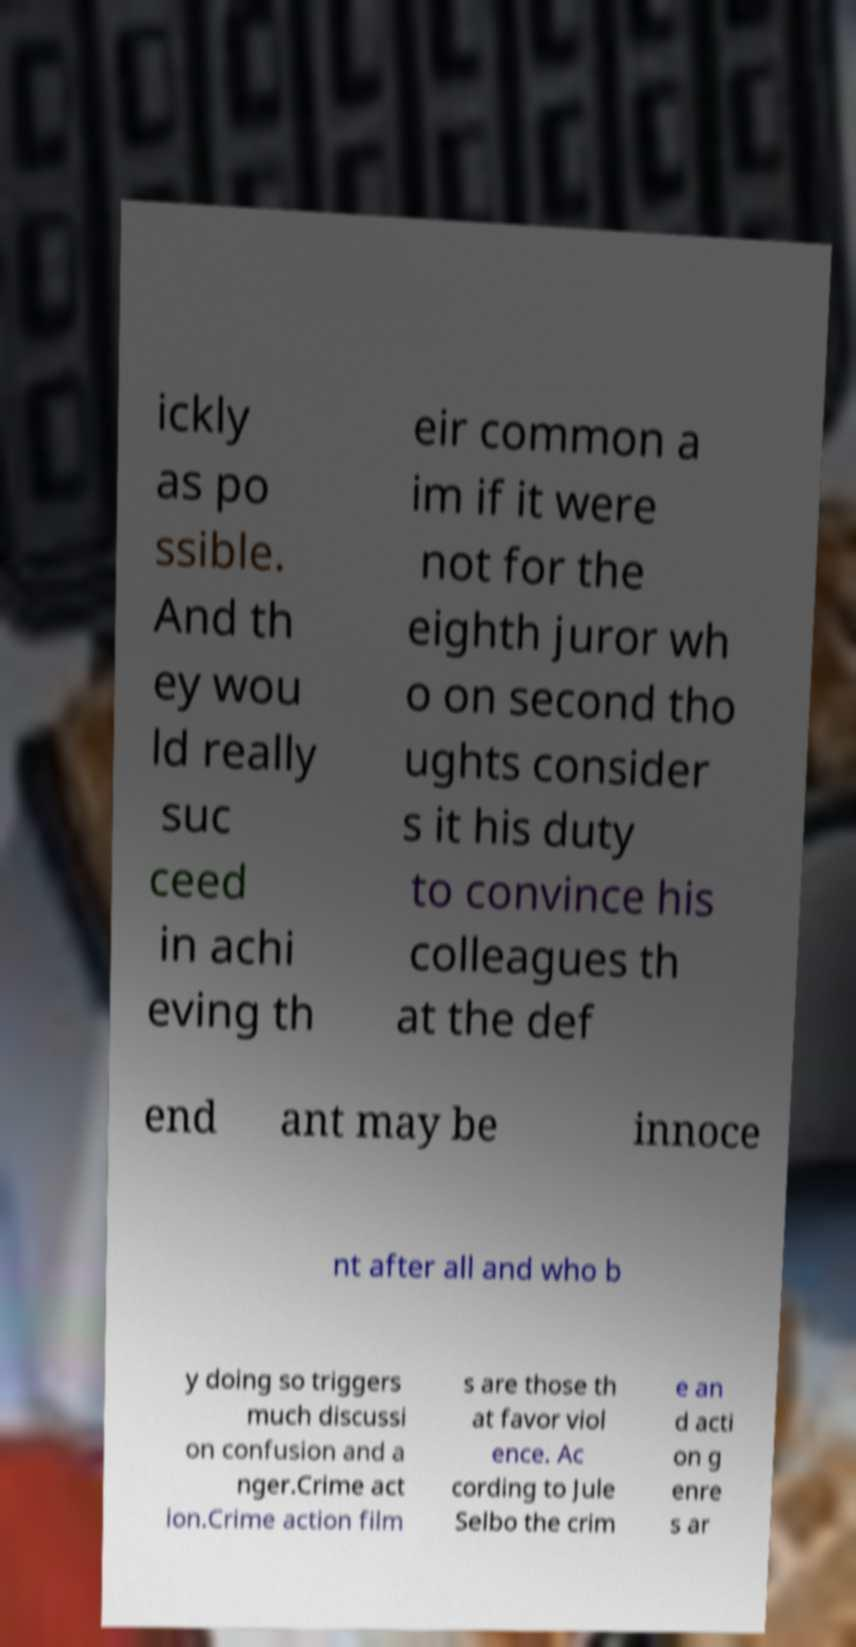For documentation purposes, I need the text within this image transcribed. Could you provide that? ickly as po ssible. And th ey wou ld really suc ceed in achi eving th eir common a im if it were not for the eighth juror wh o on second tho ughts consider s it his duty to convince his colleagues th at the def end ant may be innoce nt after all and who b y doing so triggers much discussi on confusion and a nger.Crime act ion.Crime action film s are those th at favor viol ence. Ac cording to Jule Selbo the crim e an d acti on g enre s ar 